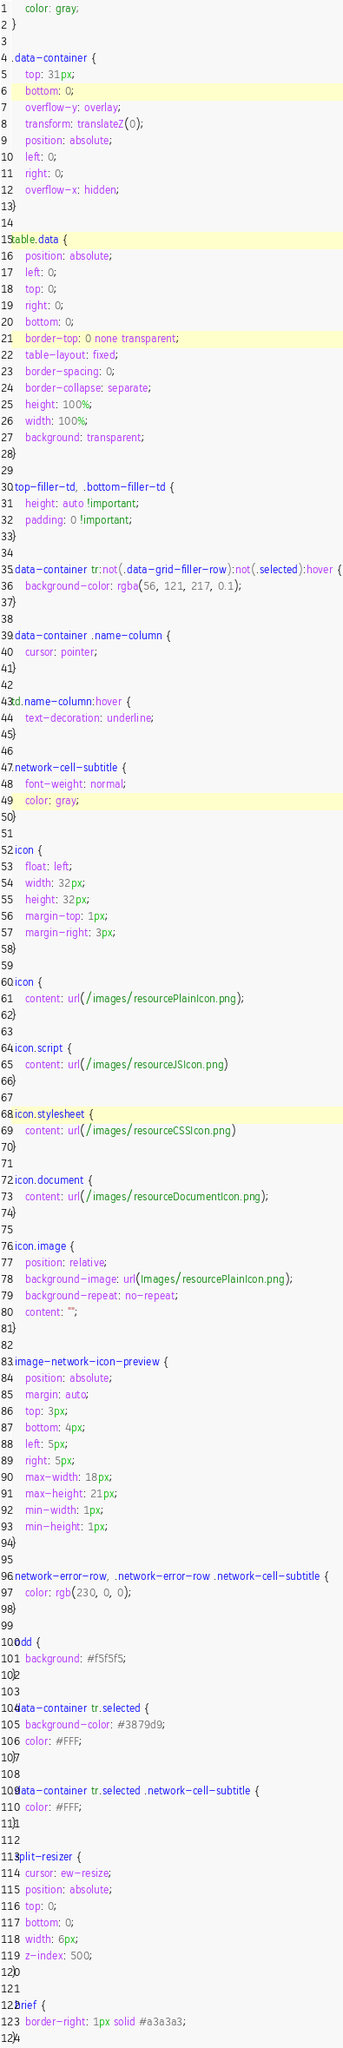<code> <loc_0><loc_0><loc_500><loc_500><_CSS_>	color: gray;
}

.data-container {
	top: 31px;
	bottom: 0;
	overflow-y: overlay;
	transform: translateZ(0);
	position: absolute;
	left: 0;
	right: 0;
	overflow-x: hidden;
}

table.data {
	position: absolute;
	left: 0;
	top: 0;
	right: 0;
	bottom: 0;
	border-top: 0 none transparent;
	table-layout: fixed;
	border-spacing: 0;
	border-collapse: separate;
	height: 100%;
	width: 100%;
	background: transparent;
}

.top-filler-td, .bottom-filler-td {
	height: auto !important;
	padding: 0 !important;
}

.data-container tr:not(.data-grid-filler-row):not(.selected):hover {
	background-color: rgba(56, 121, 217, 0.1);
}

.data-container .name-column {
	cursor: pointer;
}

td.name-column:hover {
	text-decoration: underline;
}

.network-cell-subtitle {
	font-weight: normal;
	color: gray;
}

.icon {
	float: left;
	width: 32px;
	height: 32px;
	margin-top: 1px;
	margin-right: 3px;
}

.icon {
	content: url(/images/resourcePlainIcon.png);
}

.icon.script {
	content: url(/images/resourceJSIcon.png)
}

.icon.stylesheet {
	content: url(/images/resourceCSSIcon.png)
}

.icon.document {
	content: url(/images/resourceDocumentIcon.png);
}

.icon.image {
	position: relative;
	background-image: url(Images/resourcePlainIcon.png);
	background-repeat: no-repeat;
	content: "";
}

.image-network-icon-preview {
	position: absolute;
	margin: auto;
	top: 3px;
	bottom: 4px;
	left: 5px;
	right: 5px;
	max-width: 18px;
	max-height: 21px;
	min-width: 1px;
	min-height: 1px;
}

.network-error-row, .network-error-row .network-cell-subtitle {
	color: rgb(230, 0, 0);
}

.odd {
	background: #f5f5f5;
}

.data-container tr.selected {
	background-color: #3879d9;
	color: #FFF;
}

.data-container tr.selected .network-cell-subtitle {
	color: #FFF;
}

.split-resizer {
	cursor: ew-resize;
	position: absolute;
	top: 0;
	bottom: 0;
	width: 6px;
	z-index: 500;
}

.brief {
	border-right: 1px solid #a3a3a3;
}
</code> 